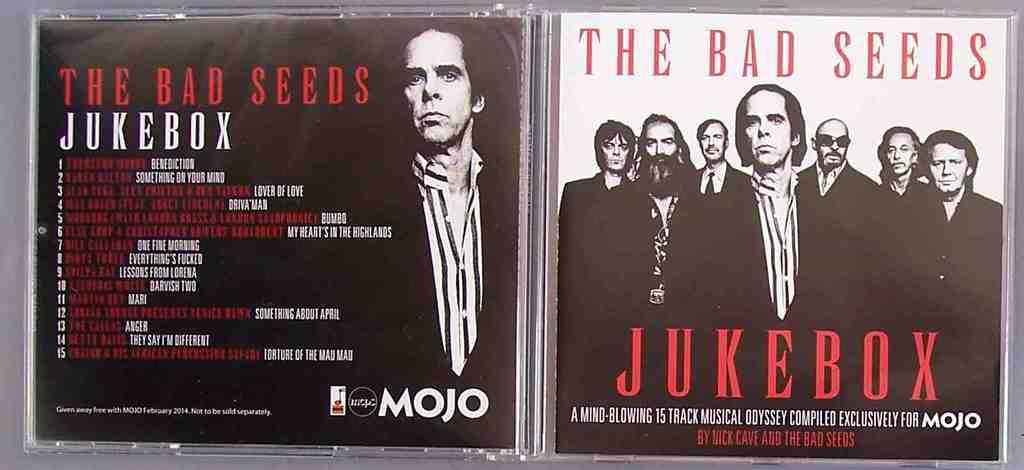What object in the image has a label on it? There is a label on a compact disc in the image. Can you describe the label on the compact disc? Unfortunately, the details of the label cannot be determined from the image alone. What is the primary purpose of a compact disc? Compact discs are typically used for storing and playing digital data, such as music or software. How many women are playing volleyball in the image? There are no women or volleyball games depicted in the image; it features a compact disc with a label. What type of quartz can be seen in the image? There is no quartz present in the image; it features a compact disc with a label. 